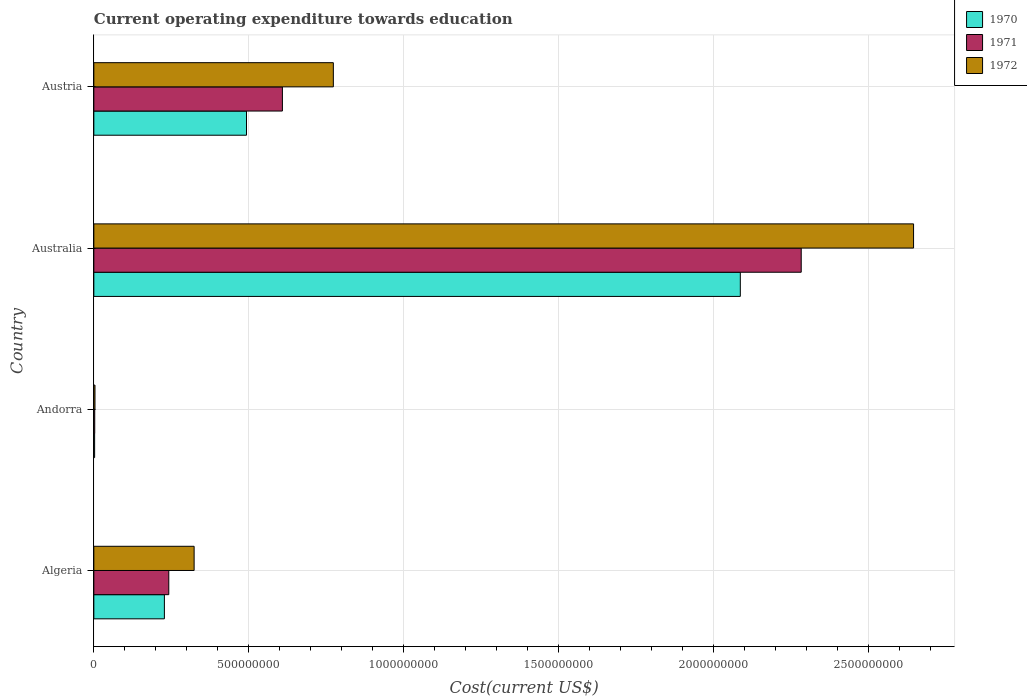How many different coloured bars are there?
Offer a terse response. 3. How many groups of bars are there?
Offer a very short reply. 4. Are the number of bars per tick equal to the number of legend labels?
Offer a terse response. Yes. Are the number of bars on each tick of the Y-axis equal?
Ensure brevity in your answer.  Yes. How many bars are there on the 1st tick from the top?
Your answer should be compact. 3. How many bars are there on the 2nd tick from the bottom?
Provide a succinct answer. 3. What is the expenditure towards education in 1970 in Austria?
Ensure brevity in your answer.  4.92e+08. Across all countries, what is the maximum expenditure towards education in 1971?
Your answer should be very brief. 2.28e+09. Across all countries, what is the minimum expenditure towards education in 1971?
Your answer should be very brief. 2.95e+06. In which country was the expenditure towards education in 1971 maximum?
Your response must be concise. Australia. In which country was the expenditure towards education in 1970 minimum?
Offer a terse response. Andorra. What is the total expenditure towards education in 1972 in the graph?
Your response must be concise. 3.74e+09. What is the difference between the expenditure towards education in 1970 in Algeria and that in Australia?
Provide a succinct answer. -1.86e+09. What is the difference between the expenditure towards education in 1972 in Andorra and the expenditure towards education in 1971 in Australia?
Offer a terse response. -2.28e+09. What is the average expenditure towards education in 1971 per country?
Your response must be concise. 7.84e+08. What is the difference between the expenditure towards education in 1971 and expenditure towards education in 1970 in Australia?
Your answer should be very brief. 1.96e+08. In how many countries, is the expenditure towards education in 1972 greater than 700000000 US$?
Keep it short and to the point. 2. What is the ratio of the expenditure towards education in 1972 in Australia to that in Austria?
Keep it short and to the point. 3.42. Is the expenditure towards education in 1972 in Algeria less than that in Andorra?
Provide a short and direct response. No. What is the difference between the highest and the second highest expenditure towards education in 1971?
Your answer should be compact. 1.67e+09. What is the difference between the highest and the lowest expenditure towards education in 1970?
Ensure brevity in your answer.  2.08e+09. In how many countries, is the expenditure towards education in 1970 greater than the average expenditure towards education in 1970 taken over all countries?
Offer a very short reply. 1. What does the 1st bar from the top in Austria represents?
Provide a short and direct response. 1972. Is it the case that in every country, the sum of the expenditure towards education in 1970 and expenditure towards education in 1971 is greater than the expenditure towards education in 1972?
Your answer should be very brief. Yes. Are all the bars in the graph horizontal?
Offer a very short reply. Yes. How many countries are there in the graph?
Provide a succinct answer. 4. Does the graph contain any zero values?
Offer a very short reply. No. Does the graph contain grids?
Make the answer very short. Yes. How many legend labels are there?
Your answer should be compact. 3. What is the title of the graph?
Your answer should be compact. Current operating expenditure towards education. Does "2008" appear as one of the legend labels in the graph?
Offer a terse response. No. What is the label or title of the X-axis?
Ensure brevity in your answer.  Cost(current US$). What is the Cost(current US$) in 1970 in Algeria?
Offer a very short reply. 2.28e+08. What is the Cost(current US$) in 1971 in Algeria?
Keep it short and to the point. 2.42e+08. What is the Cost(current US$) in 1972 in Algeria?
Keep it short and to the point. 3.23e+08. What is the Cost(current US$) of 1970 in Andorra?
Your response must be concise. 2.59e+06. What is the Cost(current US$) in 1971 in Andorra?
Keep it short and to the point. 2.95e+06. What is the Cost(current US$) of 1972 in Andorra?
Provide a short and direct response. 3.74e+06. What is the Cost(current US$) in 1970 in Australia?
Provide a succinct answer. 2.09e+09. What is the Cost(current US$) of 1971 in Australia?
Give a very brief answer. 2.28e+09. What is the Cost(current US$) of 1972 in Australia?
Your response must be concise. 2.64e+09. What is the Cost(current US$) of 1970 in Austria?
Offer a very short reply. 4.92e+08. What is the Cost(current US$) of 1971 in Austria?
Provide a short and direct response. 6.08e+08. What is the Cost(current US$) of 1972 in Austria?
Provide a short and direct response. 7.73e+08. Across all countries, what is the maximum Cost(current US$) in 1970?
Offer a terse response. 2.09e+09. Across all countries, what is the maximum Cost(current US$) in 1971?
Keep it short and to the point. 2.28e+09. Across all countries, what is the maximum Cost(current US$) of 1972?
Give a very brief answer. 2.64e+09. Across all countries, what is the minimum Cost(current US$) in 1970?
Ensure brevity in your answer.  2.59e+06. Across all countries, what is the minimum Cost(current US$) in 1971?
Your response must be concise. 2.95e+06. Across all countries, what is the minimum Cost(current US$) in 1972?
Your response must be concise. 3.74e+06. What is the total Cost(current US$) of 1970 in the graph?
Your answer should be very brief. 2.81e+09. What is the total Cost(current US$) of 1971 in the graph?
Your answer should be very brief. 3.13e+09. What is the total Cost(current US$) of 1972 in the graph?
Your answer should be very brief. 3.74e+09. What is the difference between the Cost(current US$) of 1970 in Algeria and that in Andorra?
Your response must be concise. 2.25e+08. What is the difference between the Cost(current US$) in 1971 in Algeria and that in Andorra?
Make the answer very short. 2.39e+08. What is the difference between the Cost(current US$) of 1972 in Algeria and that in Andorra?
Offer a very short reply. 3.20e+08. What is the difference between the Cost(current US$) of 1970 in Algeria and that in Australia?
Your answer should be very brief. -1.86e+09. What is the difference between the Cost(current US$) in 1971 in Algeria and that in Australia?
Your response must be concise. -2.04e+09. What is the difference between the Cost(current US$) in 1972 in Algeria and that in Australia?
Your answer should be very brief. -2.32e+09. What is the difference between the Cost(current US$) of 1970 in Algeria and that in Austria?
Your answer should be very brief. -2.65e+08. What is the difference between the Cost(current US$) in 1971 in Algeria and that in Austria?
Your response must be concise. -3.66e+08. What is the difference between the Cost(current US$) in 1972 in Algeria and that in Austria?
Your answer should be very brief. -4.49e+08. What is the difference between the Cost(current US$) in 1970 in Andorra and that in Australia?
Offer a very short reply. -2.08e+09. What is the difference between the Cost(current US$) in 1971 in Andorra and that in Australia?
Your response must be concise. -2.28e+09. What is the difference between the Cost(current US$) in 1972 in Andorra and that in Australia?
Your response must be concise. -2.64e+09. What is the difference between the Cost(current US$) in 1970 in Andorra and that in Austria?
Your response must be concise. -4.90e+08. What is the difference between the Cost(current US$) of 1971 in Andorra and that in Austria?
Provide a succinct answer. -6.05e+08. What is the difference between the Cost(current US$) of 1972 in Andorra and that in Austria?
Your response must be concise. -7.69e+08. What is the difference between the Cost(current US$) in 1970 in Australia and that in Austria?
Give a very brief answer. 1.59e+09. What is the difference between the Cost(current US$) of 1971 in Australia and that in Austria?
Make the answer very short. 1.67e+09. What is the difference between the Cost(current US$) of 1972 in Australia and that in Austria?
Your response must be concise. 1.87e+09. What is the difference between the Cost(current US$) in 1970 in Algeria and the Cost(current US$) in 1971 in Andorra?
Offer a very short reply. 2.25e+08. What is the difference between the Cost(current US$) of 1970 in Algeria and the Cost(current US$) of 1972 in Andorra?
Provide a succinct answer. 2.24e+08. What is the difference between the Cost(current US$) of 1971 in Algeria and the Cost(current US$) of 1972 in Andorra?
Make the answer very short. 2.38e+08. What is the difference between the Cost(current US$) in 1970 in Algeria and the Cost(current US$) in 1971 in Australia?
Your answer should be very brief. -2.05e+09. What is the difference between the Cost(current US$) in 1970 in Algeria and the Cost(current US$) in 1972 in Australia?
Ensure brevity in your answer.  -2.42e+09. What is the difference between the Cost(current US$) of 1971 in Algeria and the Cost(current US$) of 1972 in Australia?
Give a very brief answer. -2.40e+09. What is the difference between the Cost(current US$) of 1970 in Algeria and the Cost(current US$) of 1971 in Austria?
Make the answer very short. -3.81e+08. What is the difference between the Cost(current US$) in 1970 in Algeria and the Cost(current US$) in 1972 in Austria?
Provide a succinct answer. -5.45e+08. What is the difference between the Cost(current US$) in 1971 in Algeria and the Cost(current US$) in 1972 in Austria?
Ensure brevity in your answer.  -5.31e+08. What is the difference between the Cost(current US$) in 1970 in Andorra and the Cost(current US$) in 1971 in Australia?
Give a very brief answer. -2.28e+09. What is the difference between the Cost(current US$) of 1970 in Andorra and the Cost(current US$) of 1972 in Australia?
Give a very brief answer. -2.64e+09. What is the difference between the Cost(current US$) in 1971 in Andorra and the Cost(current US$) in 1972 in Australia?
Provide a short and direct response. -2.64e+09. What is the difference between the Cost(current US$) of 1970 in Andorra and the Cost(current US$) of 1971 in Austria?
Your response must be concise. -6.06e+08. What is the difference between the Cost(current US$) in 1970 in Andorra and the Cost(current US$) in 1972 in Austria?
Your response must be concise. -7.70e+08. What is the difference between the Cost(current US$) in 1971 in Andorra and the Cost(current US$) in 1972 in Austria?
Provide a short and direct response. -7.70e+08. What is the difference between the Cost(current US$) of 1970 in Australia and the Cost(current US$) of 1971 in Austria?
Offer a very short reply. 1.48e+09. What is the difference between the Cost(current US$) of 1970 in Australia and the Cost(current US$) of 1972 in Austria?
Provide a short and direct response. 1.31e+09. What is the difference between the Cost(current US$) of 1971 in Australia and the Cost(current US$) of 1972 in Austria?
Make the answer very short. 1.51e+09. What is the average Cost(current US$) in 1970 per country?
Your answer should be very brief. 7.02e+08. What is the average Cost(current US$) of 1971 per country?
Ensure brevity in your answer.  7.84e+08. What is the average Cost(current US$) in 1972 per country?
Offer a terse response. 9.36e+08. What is the difference between the Cost(current US$) of 1970 and Cost(current US$) of 1971 in Algeria?
Offer a terse response. -1.41e+07. What is the difference between the Cost(current US$) of 1970 and Cost(current US$) of 1972 in Algeria?
Make the answer very short. -9.59e+07. What is the difference between the Cost(current US$) in 1971 and Cost(current US$) in 1972 in Algeria?
Provide a succinct answer. -8.17e+07. What is the difference between the Cost(current US$) in 1970 and Cost(current US$) in 1971 in Andorra?
Ensure brevity in your answer.  -3.56e+05. What is the difference between the Cost(current US$) in 1970 and Cost(current US$) in 1972 in Andorra?
Your response must be concise. -1.15e+06. What is the difference between the Cost(current US$) of 1971 and Cost(current US$) of 1972 in Andorra?
Your response must be concise. -7.92e+05. What is the difference between the Cost(current US$) of 1970 and Cost(current US$) of 1971 in Australia?
Make the answer very short. -1.96e+08. What is the difference between the Cost(current US$) in 1970 and Cost(current US$) in 1972 in Australia?
Offer a very short reply. -5.59e+08. What is the difference between the Cost(current US$) in 1971 and Cost(current US$) in 1972 in Australia?
Your answer should be very brief. -3.62e+08. What is the difference between the Cost(current US$) in 1970 and Cost(current US$) in 1971 in Austria?
Give a very brief answer. -1.16e+08. What is the difference between the Cost(current US$) of 1970 and Cost(current US$) of 1972 in Austria?
Provide a short and direct response. -2.80e+08. What is the difference between the Cost(current US$) in 1971 and Cost(current US$) in 1972 in Austria?
Offer a terse response. -1.64e+08. What is the ratio of the Cost(current US$) in 1970 in Algeria to that in Andorra?
Your answer should be compact. 87.73. What is the ratio of the Cost(current US$) in 1971 in Algeria to that in Andorra?
Your answer should be very brief. 81.94. What is the ratio of the Cost(current US$) in 1972 in Algeria to that in Andorra?
Ensure brevity in your answer.  86.43. What is the ratio of the Cost(current US$) in 1970 in Algeria to that in Australia?
Keep it short and to the point. 0.11. What is the ratio of the Cost(current US$) of 1971 in Algeria to that in Australia?
Ensure brevity in your answer.  0.11. What is the ratio of the Cost(current US$) of 1972 in Algeria to that in Australia?
Provide a short and direct response. 0.12. What is the ratio of the Cost(current US$) in 1970 in Algeria to that in Austria?
Give a very brief answer. 0.46. What is the ratio of the Cost(current US$) in 1971 in Algeria to that in Austria?
Make the answer very short. 0.4. What is the ratio of the Cost(current US$) of 1972 in Algeria to that in Austria?
Provide a short and direct response. 0.42. What is the ratio of the Cost(current US$) in 1970 in Andorra to that in Australia?
Keep it short and to the point. 0. What is the ratio of the Cost(current US$) of 1971 in Andorra to that in Australia?
Your answer should be compact. 0. What is the ratio of the Cost(current US$) of 1972 in Andorra to that in Australia?
Offer a terse response. 0. What is the ratio of the Cost(current US$) of 1970 in Andorra to that in Austria?
Your response must be concise. 0.01. What is the ratio of the Cost(current US$) in 1971 in Andorra to that in Austria?
Offer a very short reply. 0. What is the ratio of the Cost(current US$) of 1972 in Andorra to that in Austria?
Give a very brief answer. 0. What is the ratio of the Cost(current US$) of 1970 in Australia to that in Austria?
Ensure brevity in your answer.  4.23. What is the ratio of the Cost(current US$) in 1971 in Australia to that in Austria?
Make the answer very short. 3.75. What is the ratio of the Cost(current US$) of 1972 in Australia to that in Austria?
Your answer should be very brief. 3.42. What is the difference between the highest and the second highest Cost(current US$) in 1970?
Offer a terse response. 1.59e+09. What is the difference between the highest and the second highest Cost(current US$) of 1971?
Provide a succinct answer. 1.67e+09. What is the difference between the highest and the second highest Cost(current US$) in 1972?
Your response must be concise. 1.87e+09. What is the difference between the highest and the lowest Cost(current US$) of 1970?
Offer a very short reply. 2.08e+09. What is the difference between the highest and the lowest Cost(current US$) of 1971?
Your response must be concise. 2.28e+09. What is the difference between the highest and the lowest Cost(current US$) of 1972?
Your answer should be compact. 2.64e+09. 